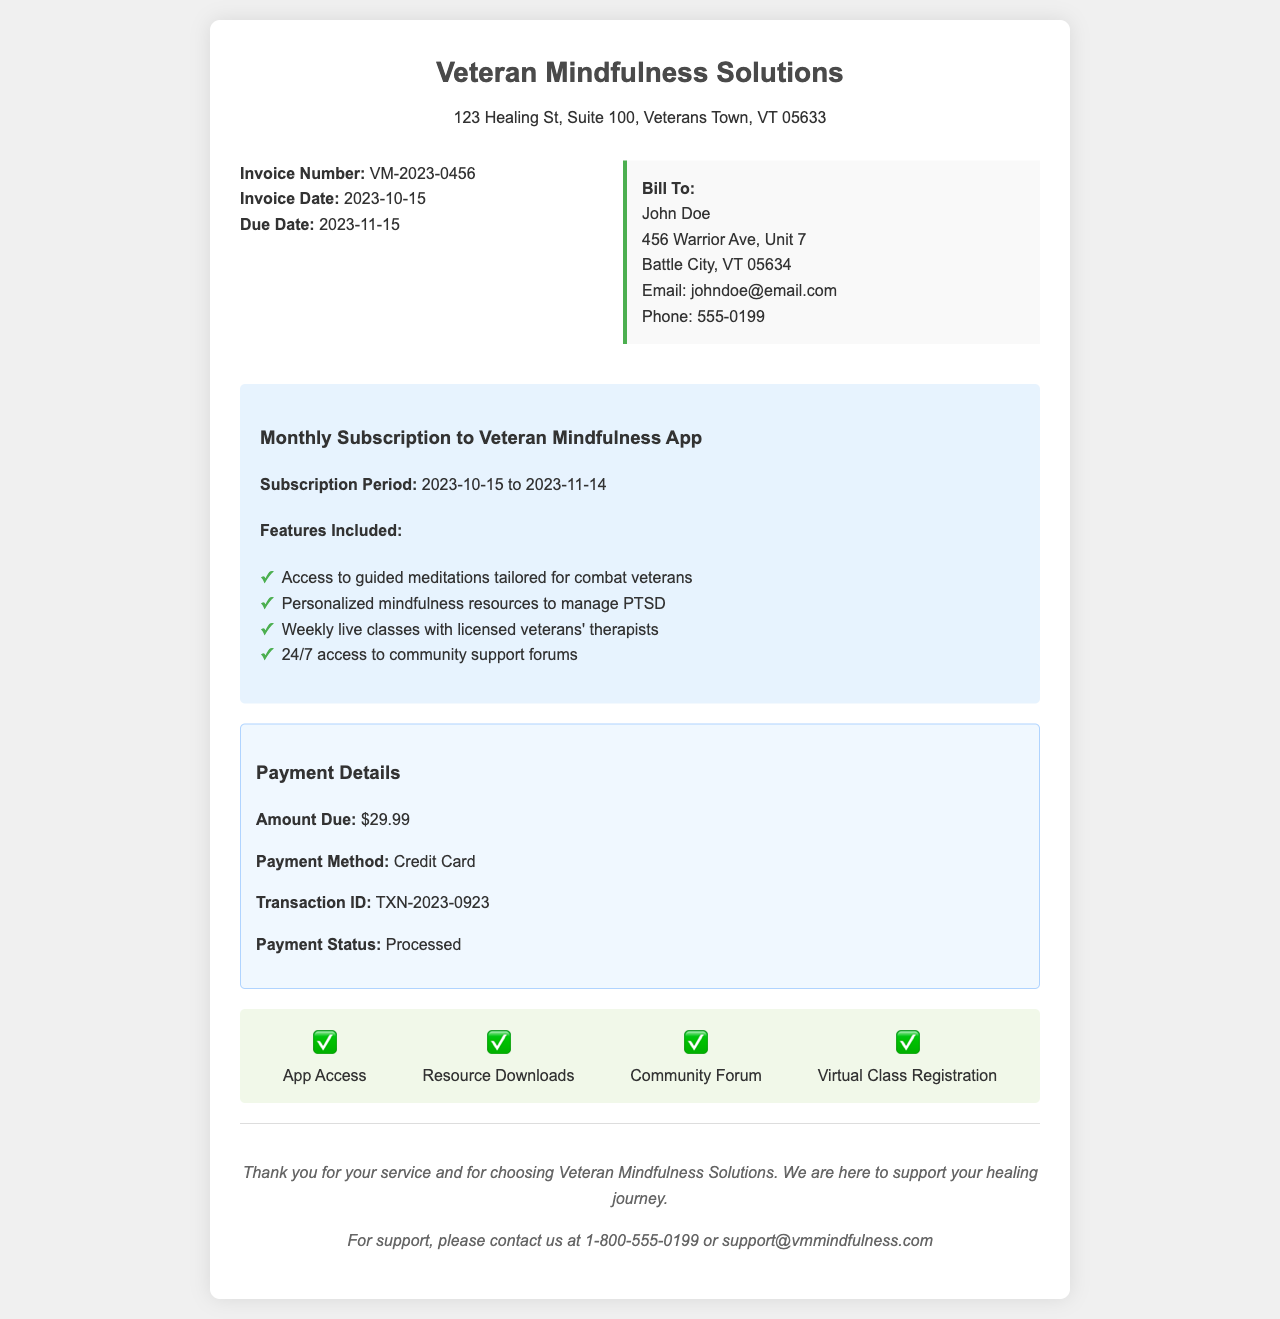What is the invoice number? The invoice number is listed prominently in the document and can be found under the invoice details section.
Answer: VM-2023-0456 What is the subscription period? The subscription period is specified in the subscription details section of the invoice.
Answer: 2023-10-15 to 2023-11-14 How much is the amount due? The amount due is clearly mentioned in the payment details section.
Answer: $29.99 What is the payment status? The payment status indicates whether the payment has been successfully processed.
Answer: Processed Who is the bill recipient? The recipient of the bill is highlighted in the recipient details section.
Answer: John Doe What features are included in the subscription? The features included in the subscription are listed in a bullet-point format in the document.
Answer: Access to guided meditations tailored for combat veterans, Personalized mindfulness resources to manage PTSD, Weekly live classes with licensed veterans' therapists, 24/7 access to community support forums What payment method was used? The payment method indicates how the payment was completed and is found in the payment details section.
Answer: Credit Card What is the due date for payment? The due date for payment is specified under invoice details and is important for timely payment.
Answer: 2023-11-15 